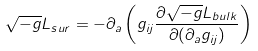Convert formula to latex. <formula><loc_0><loc_0><loc_500><loc_500>\sqrt { - g } L _ { s u r } = - \partial _ { a } \left ( g _ { i j } \frac { \partial \sqrt { - g } L _ { b u l k } } { \partial ( \partial _ { a } g _ { i j } ) } \right )</formula> 